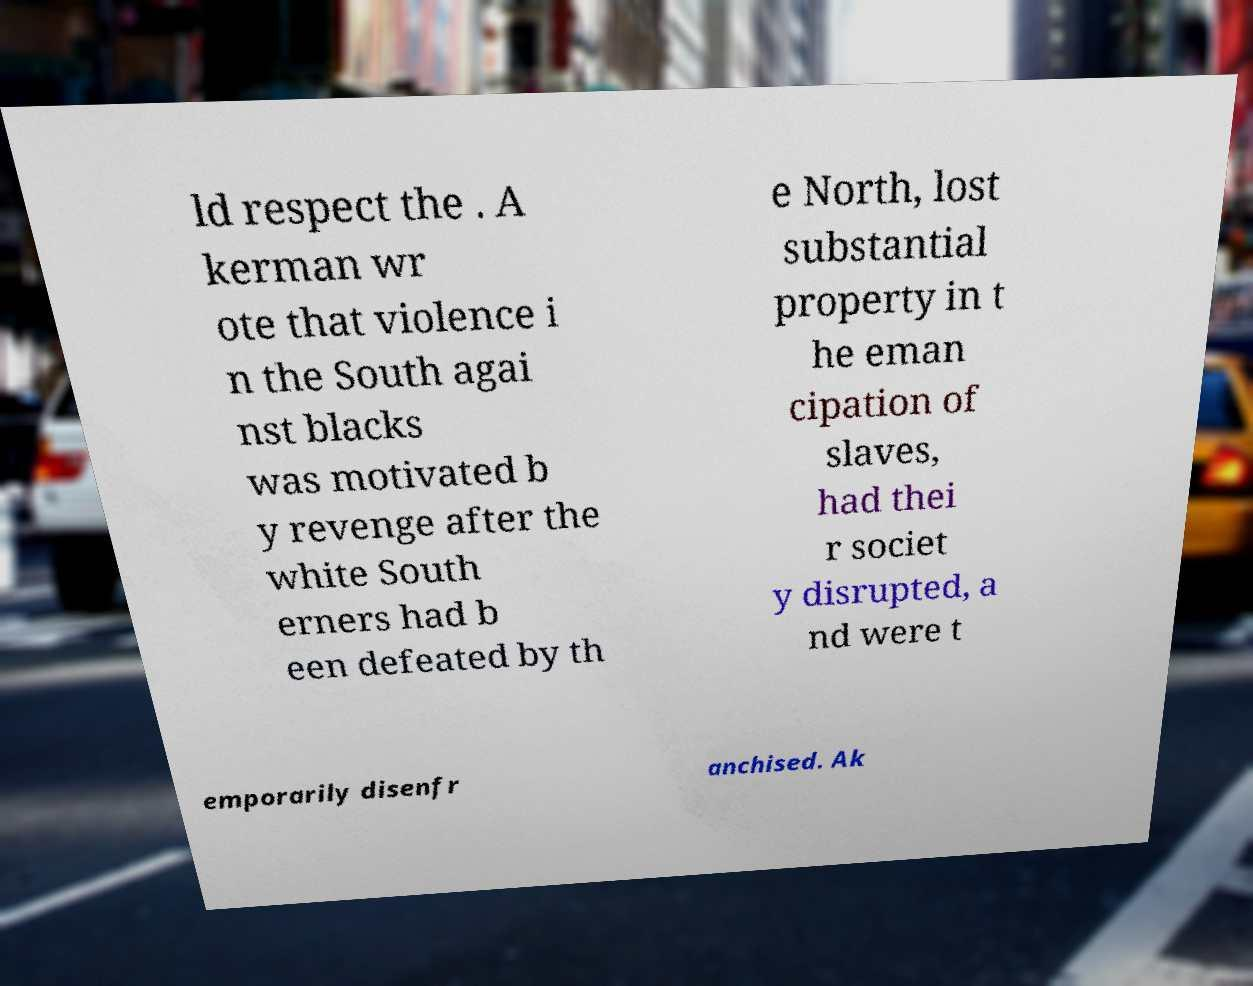There's text embedded in this image that I need extracted. Can you transcribe it verbatim? ld respect the . A kerman wr ote that violence i n the South agai nst blacks was motivated b y revenge after the white South erners had b een defeated by th e North, lost substantial property in t he eman cipation of slaves, had thei r societ y disrupted, a nd were t emporarily disenfr anchised. Ak 